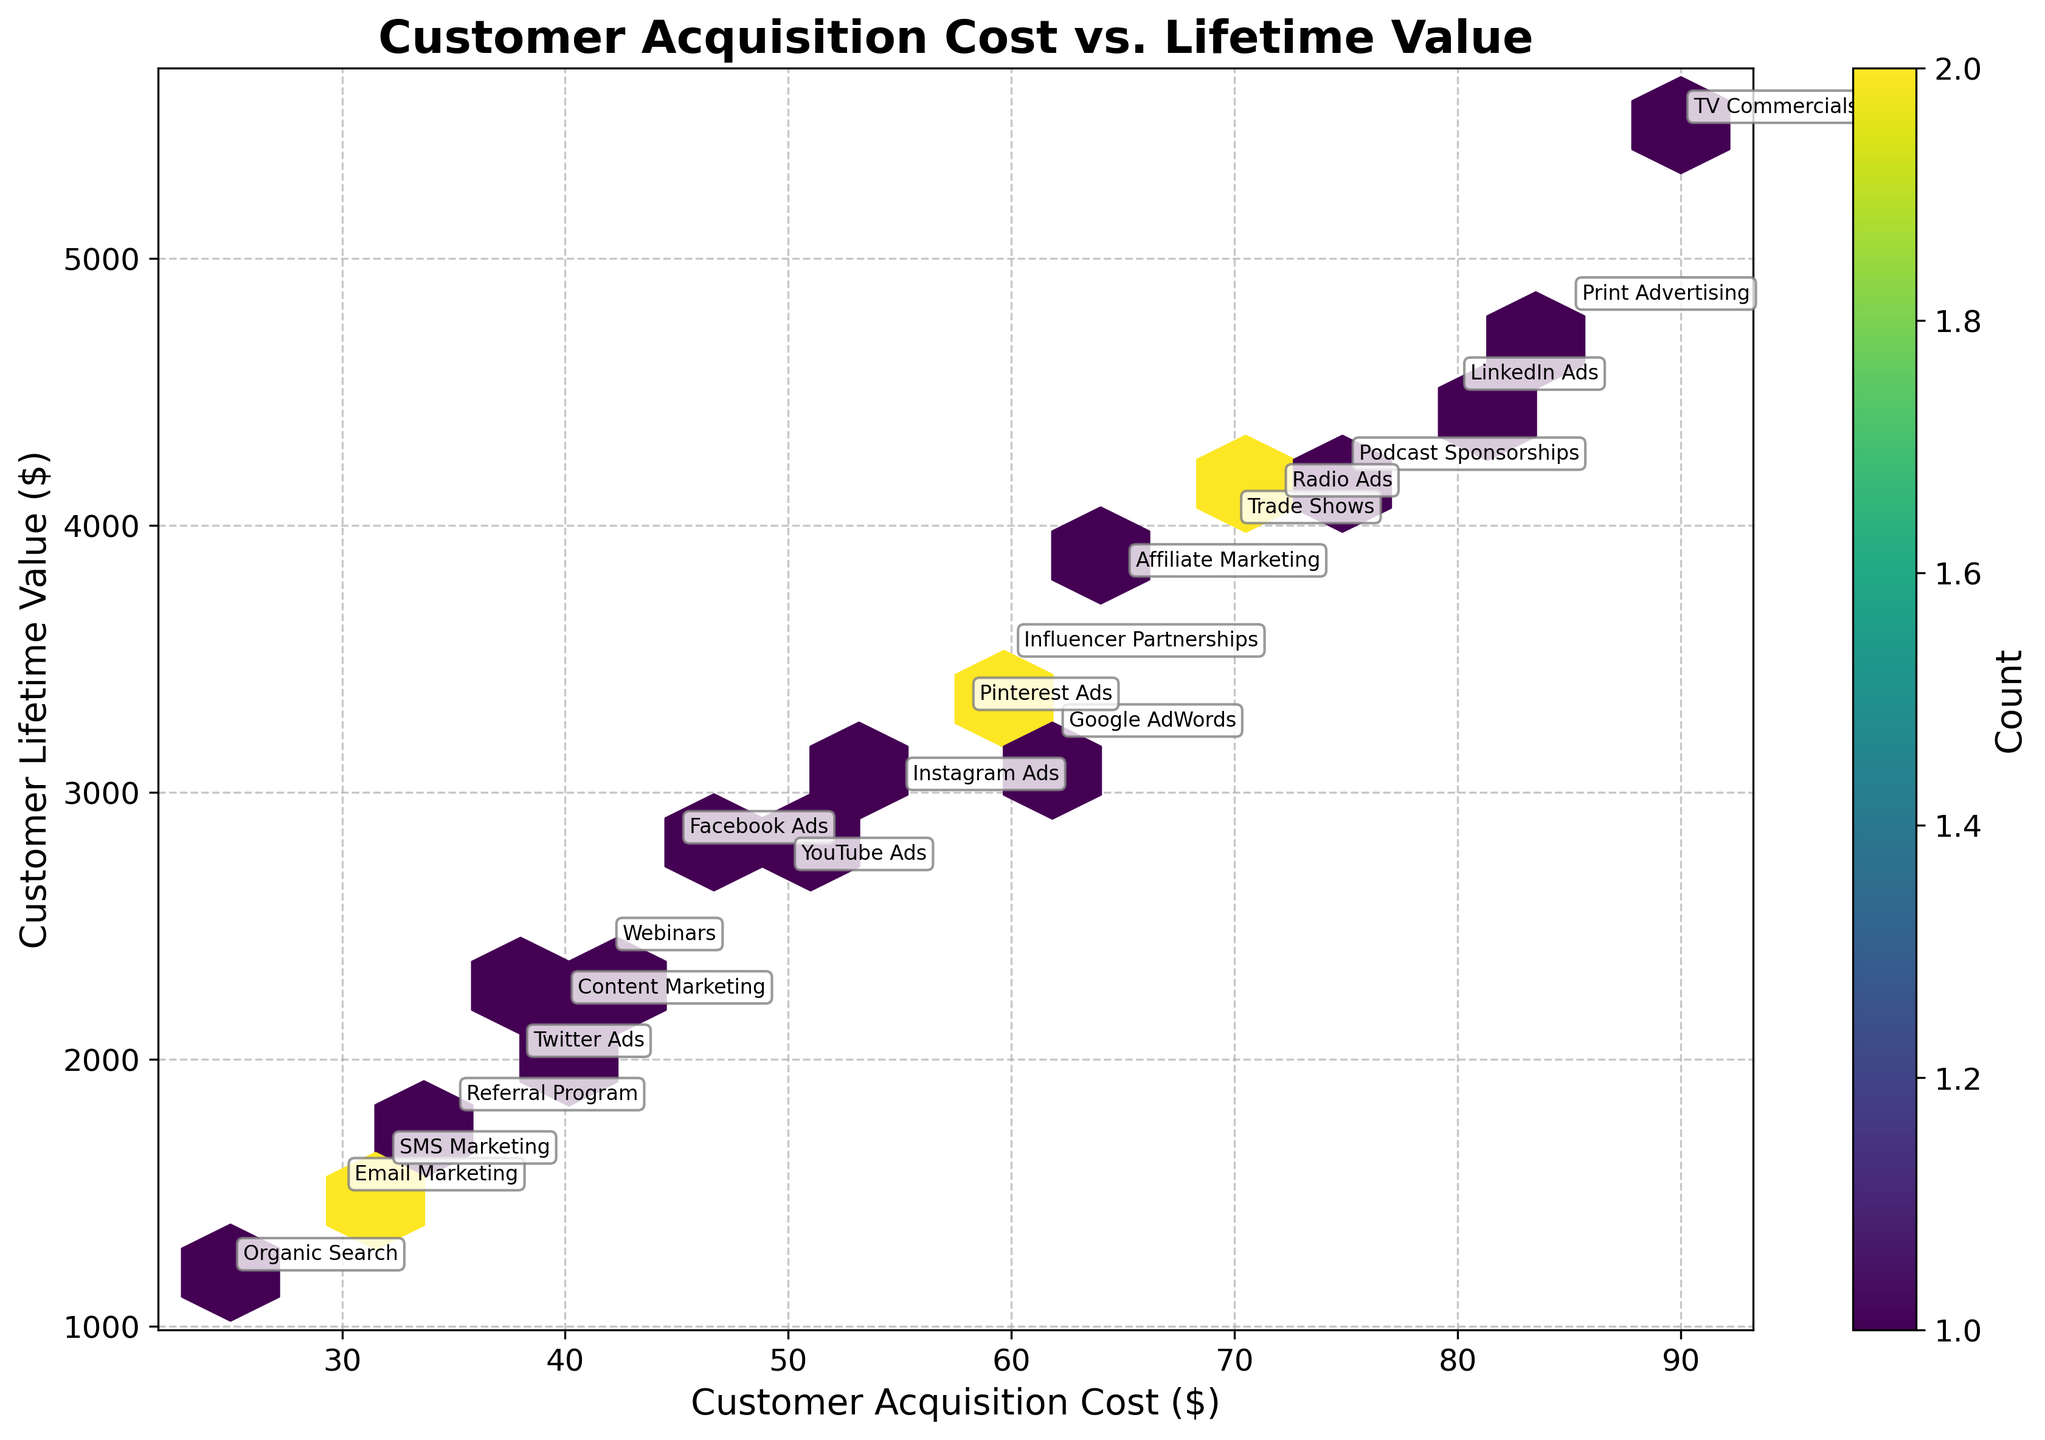What is the title of the figure? The title of the figure can be found at the top of the plot. It usually provides a brief description of what the plot is showing.
Answer: Customer Acquisition Cost vs. Lifetime Value How many bins have more than one data point? To find the number of bins with more than one data point, look for the color variations in the hexbin plot that indicate multiple data points. The color bar on the right can help identify which colors indicate counts greater than one.
Answer: 15 What is the range of Customer Acquisition Costs shown in the plot? To determine the range, check the x-axis labels, which show the minimum and maximum values of Customer Acquisition Costs plotted.
Answer: 25 to 90 Which marketing channel has the highest Customer Lifetime Value? The marketing channels are annotated on the plot at specific (x, y) points. The highest Customer Lifetime Value will be found at the highest y-value.
Answer: TV Commercials What is the relationship between Customer Acquisition Cost and Customer Lifetime Value in the hexbin plot? In the hexbin plot, observe the general trend of the data points and the density of hexbin colors. Determine if there's a pattern that indicates a positive or negative correlation between the two variables.
Answer: Positive correlation Which marketing channels have a Customer Acquisition Cost of less than 40? Identify the hexagon along the x-axis that is less than 40 and find the annotated marketing channels within this bin.
Answer: Email Marketing, Content Marketing, Referral Program, Organic Search, SMS Marketing What is the average Customer Lifetime Value for marketing channels with Customer Acquisition Costs between 40 and 60? First, identify the marketing channels within the 40 to 60 range on the x-axis. Then, sum the Customer Lifetime Values for these channels and divide by the number of channels.
Answer: (2800 + 3000 + 2200 + 2700 + 3300 + 2000 + 2400 + 3500) / 8 = 2612.5 How does the density of hexagons differ between the middle and edges of the plot? Observing the color density within the hexagons in both the middle and edge areas can show areas of high data point concentration versus sparse data points.
Answer: Higher density in the middle What is the Customer Lifetime Value of the 'LinkedIn Ads' marketing channel? Locate the annotation for 'LinkedIn Ads' on the plot and read the corresponding y-value.
Answer: 4500 Which marketing channel has a similar Customer Lifetime Value to 'Google AdWords' but a lower Customer Acquisition Cost? Identify the position of 'Google AdWords' on the plot (x = 62, y = 3200) and find an annotated channel with a similar y-value but a lower x-value.
Answer: Pinterest Ads 